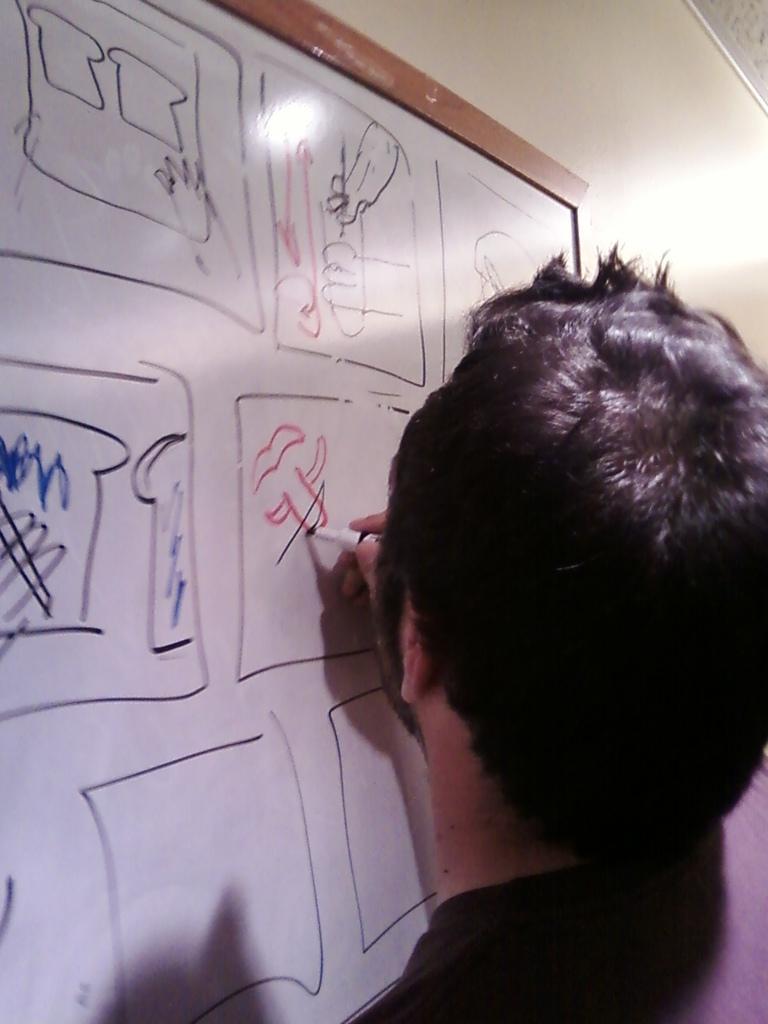In one or two sentences, can you explain what this image depicts? In the picture we can see a man drawing something on the board and man is wearing black T-shirt. 